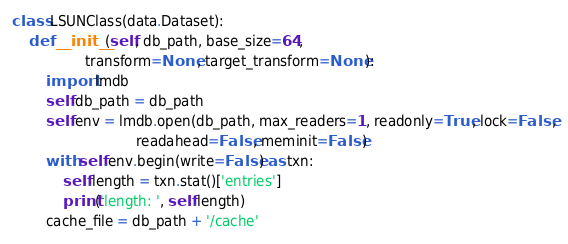Convert code to text. <code><loc_0><loc_0><loc_500><loc_500><_Python_>
class LSUNClass(data.Dataset):
    def __init__(self, db_path, base_size=64,
                 transform=None, target_transform=None):
        import lmdb
        self.db_path = db_path
        self.env = lmdb.open(db_path, max_readers=1, readonly=True, lock=False,
                             readahead=False, meminit=False)
        with self.env.begin(write=False) as txn:
            self.length = txn.stat()['entries']
            print('length: ', self.length)
        cache_file = db_path + '/cache'</code> 